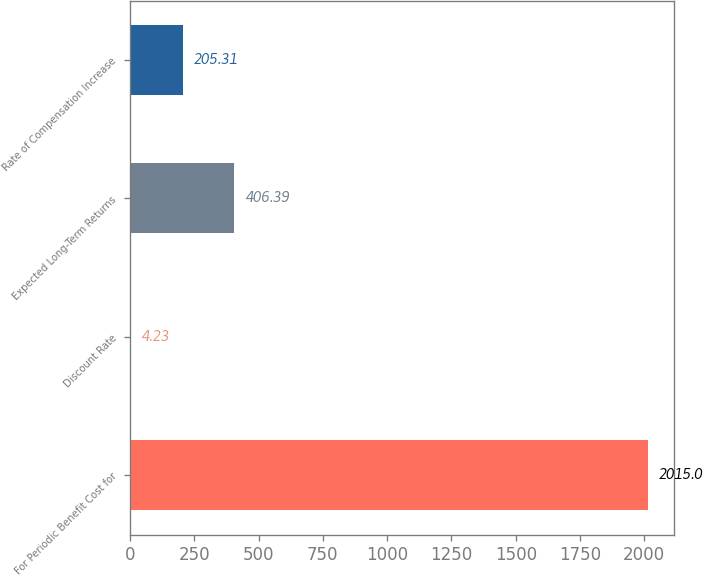Convert chart to OTSL. <chart><loc_0><loc_0><loc_500><loc_500><bar_chart><fcel>For Periodic Benefit Cost for<fcel>Discount Rate<fcel>Expected Long-Term Returns<fcel>Rate of Compensation Increase<nl><fcel>2015<fcel>4.23<fcel>406.39<fcel>205.31<nl></chart> 